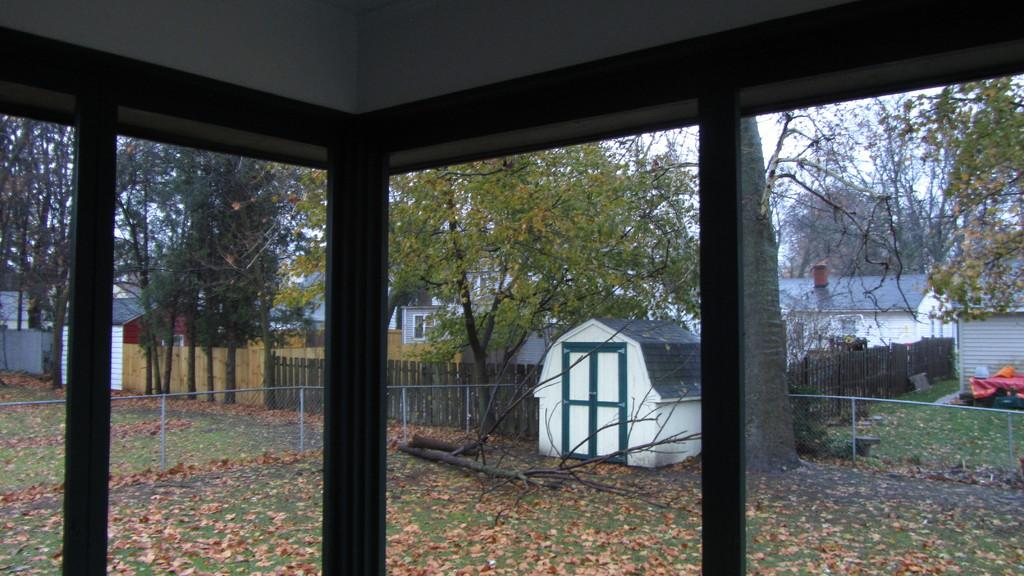What type of structures can be seen in the image? There are buildings in the image. What natural elements are present in the image? There are trees in the image. What type of barrier can be seen in the image? There is a fence in the image. What type of material is used for the rods in the image? Metal rods are visible in the image. What type of material is used for the barks in the image? Wooden barks are present in the image. Can you tell me how many toothbrushes are hanging on the fence in the image? There are no toothbrushes present in the image; the fence is not associated with any toothbrushes. What type of bead is used to decorate the buildings in the image? There is no mention of beads or any decorative elements on the buildings in the image. 